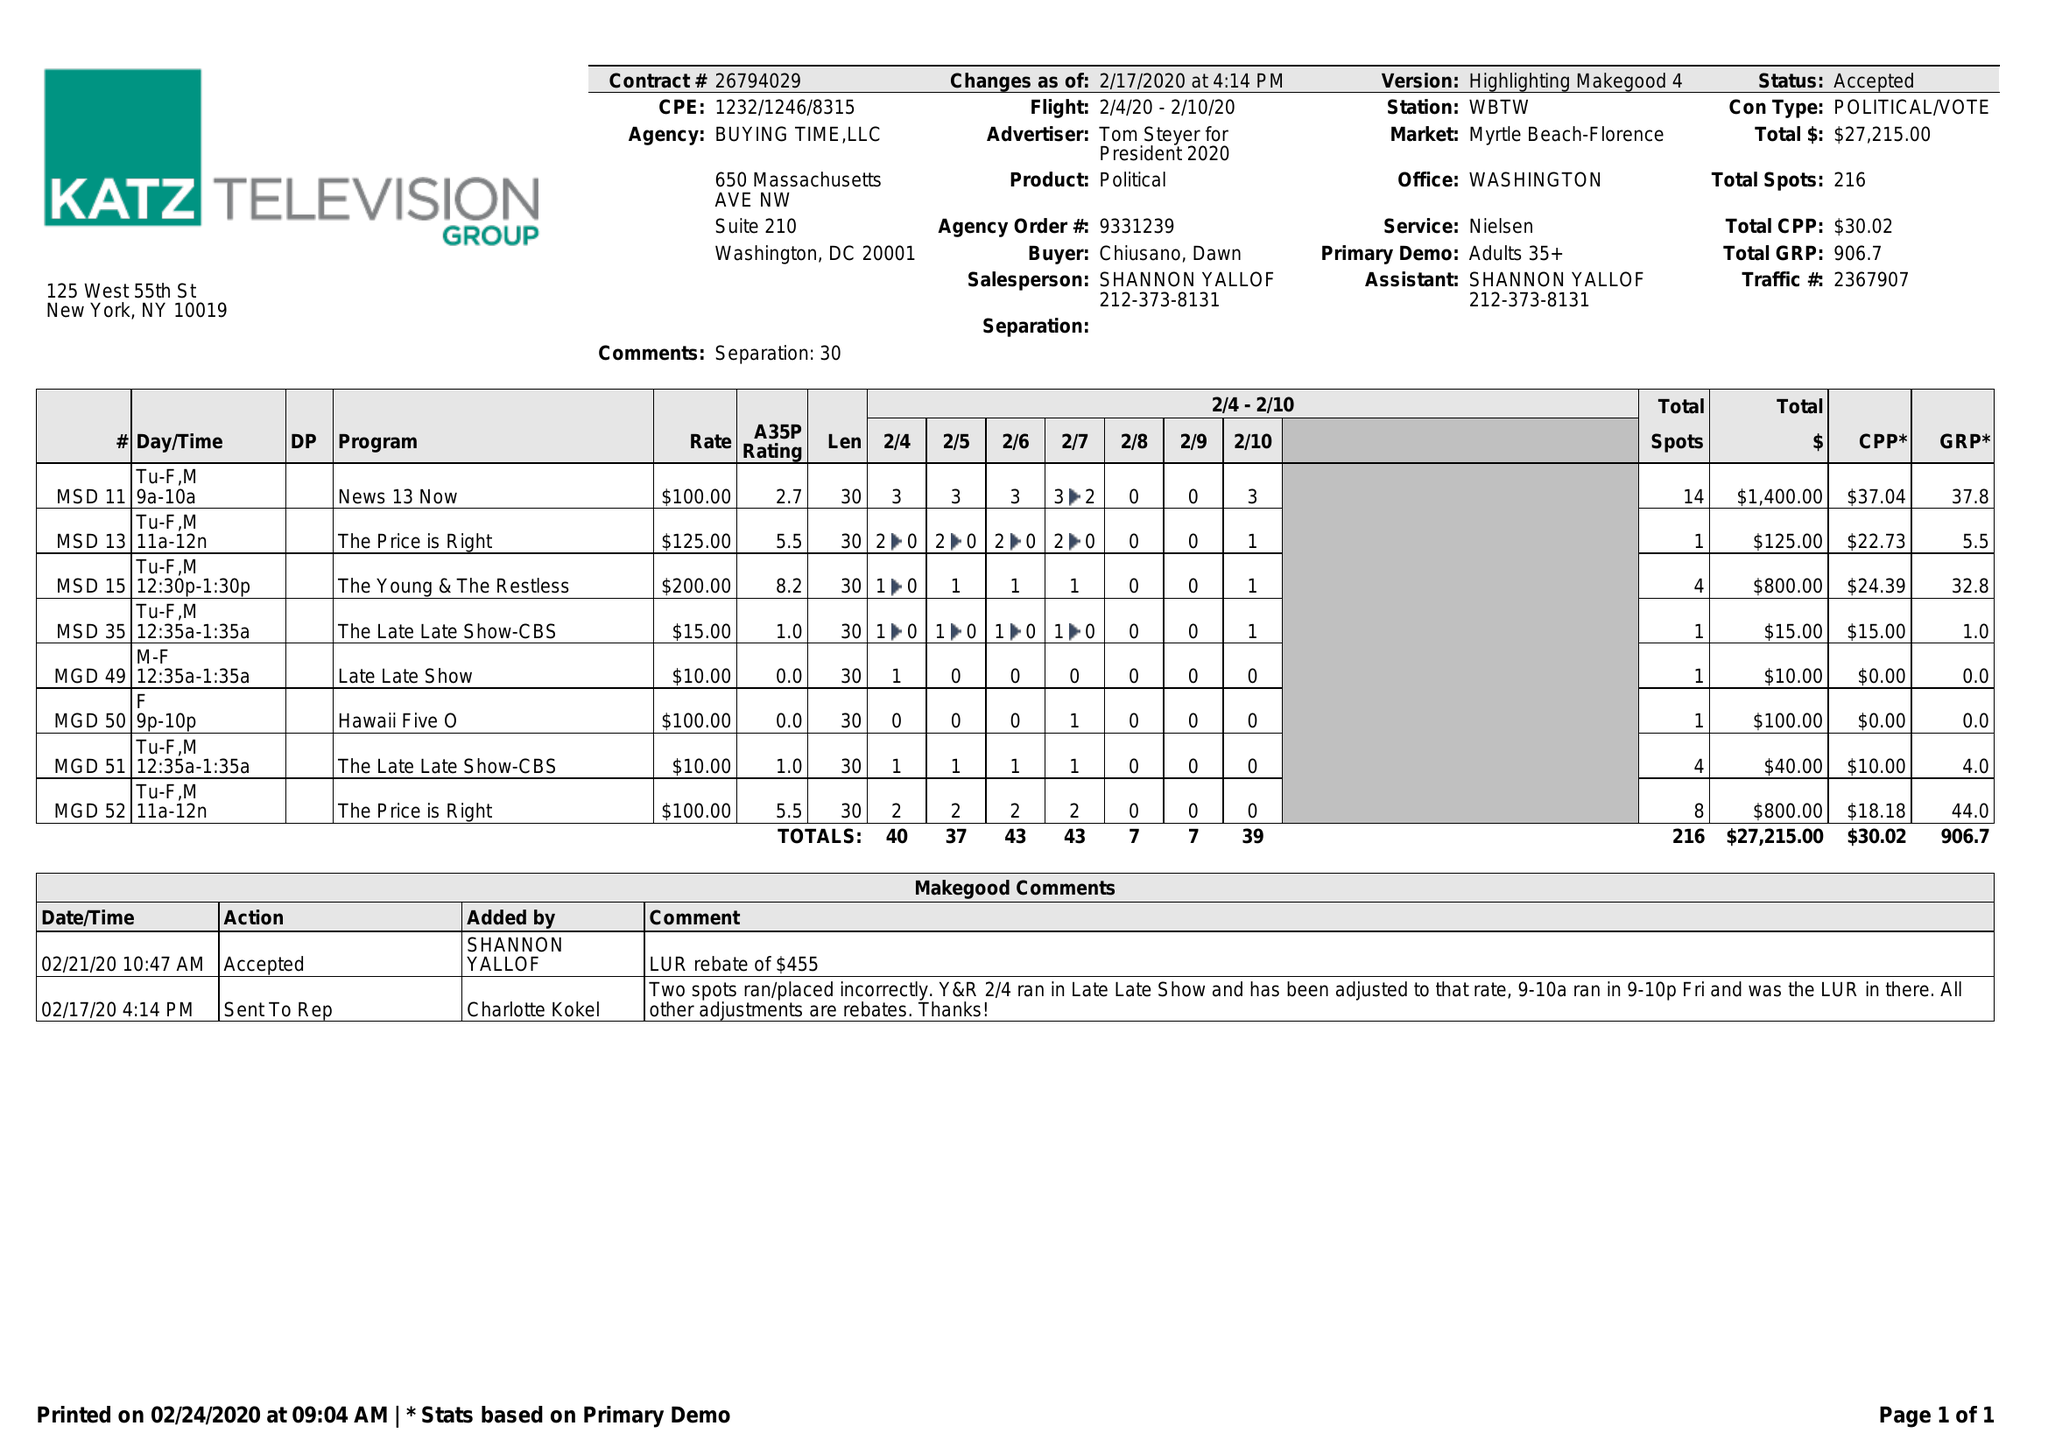What is the value for the flight_to?
Answer the question using a single word or phrase. 02/10/20 